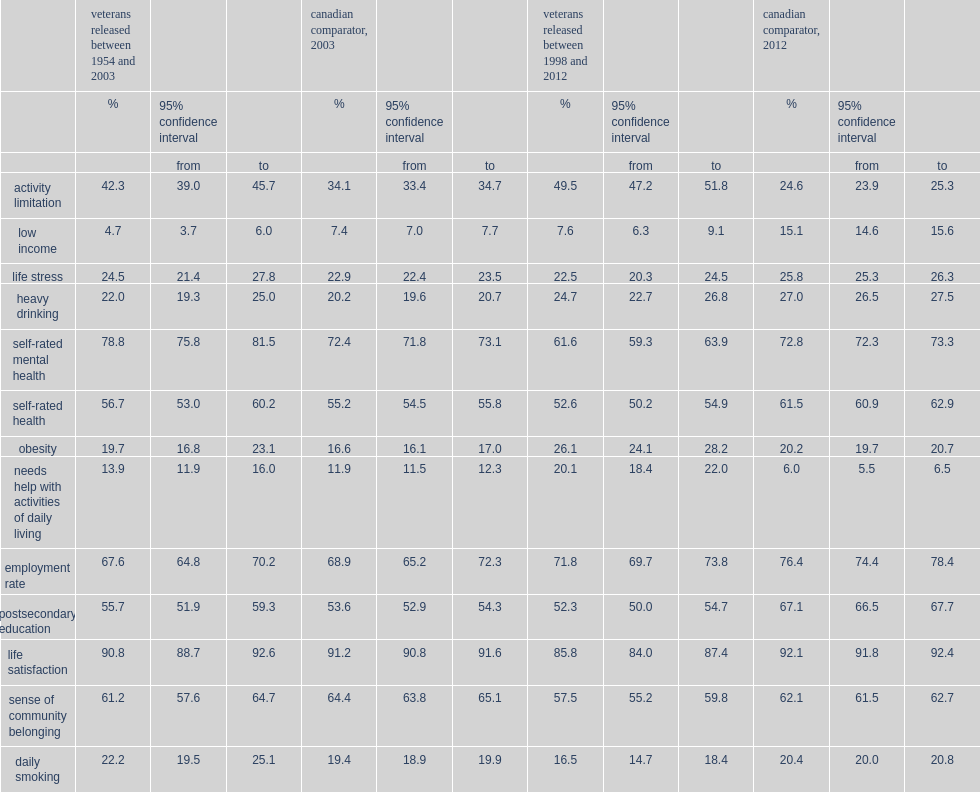Which type of people's self-rated mental health was better, earlier-era veterans or canadian comparator? Veterans released between 1954 and 2003. Which type of people's self-rated mental health was worse, recent-era veterans or canadian comparator? Veterans released between 1998 and 2012. Which type was less likely to be daily smokers, recent-era veterans or comparable canadians? Veterans released between 1998 and 2012. 